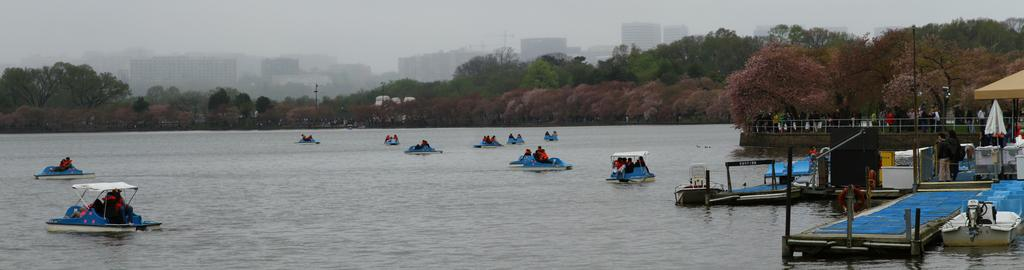What is the main structure in the image? There is a platform in the image. What are the people doing in the image? The people are in boats on the water. Where are the boats located in relation to the platform? The boats are on the water. What can be seen in the background of the image? There are buildings, trees, and the sky visible in the background of the image. What is the number of swimmers in the water in the image? There are no swimmers visible in the image; people are in boats on the water. What is the time of day depicted in the image? The time of day cannot be determined from the image, as there is no specific information about the lighting or shadows. 